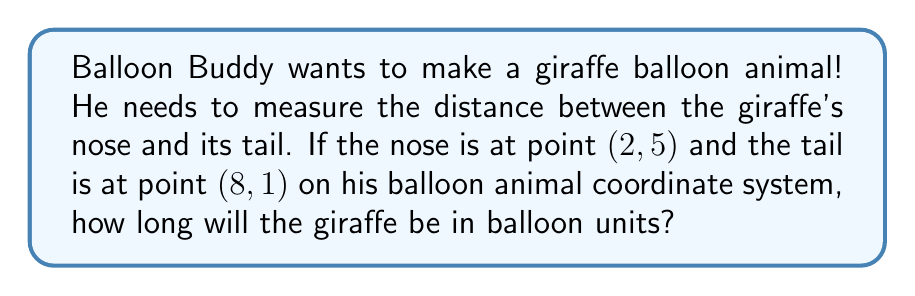Teach me how to tackle this problem. Let's solve this step-by-step:

1) To find the distance between two points, we can use the distance formula:

   $$d = \sqrt{(x_2 - x_1)^2 + (y_2 - y_1)^2}$$

2) We have:
   - Point 1 (nose): $(x_1, y_1) = (2, 5)$
   - Point 2 (tail): $(x_2, y_2) = (8, 1)$

3) Let's substitute these into our formula:

   $$d = \sqrt{(8 - 2)^2 + (1 - 5)^2}$$

4) Simplify inside the parentheses:

   $$d = \sqrt{6^2 + (-4)^2}$$

5) Calculate the squares:

   $$d = \sqrt{36 + 16}$$

6) Add inside the square root:

   $$d = \sqrt{52}$$

7) Simplify the square root:

   $$d = 2\sqrt{13}$$

This means the giraffe will be $2\sqrt{13}$ balloon units long.
Answer: $2\sqrt{13}$ balloon units 